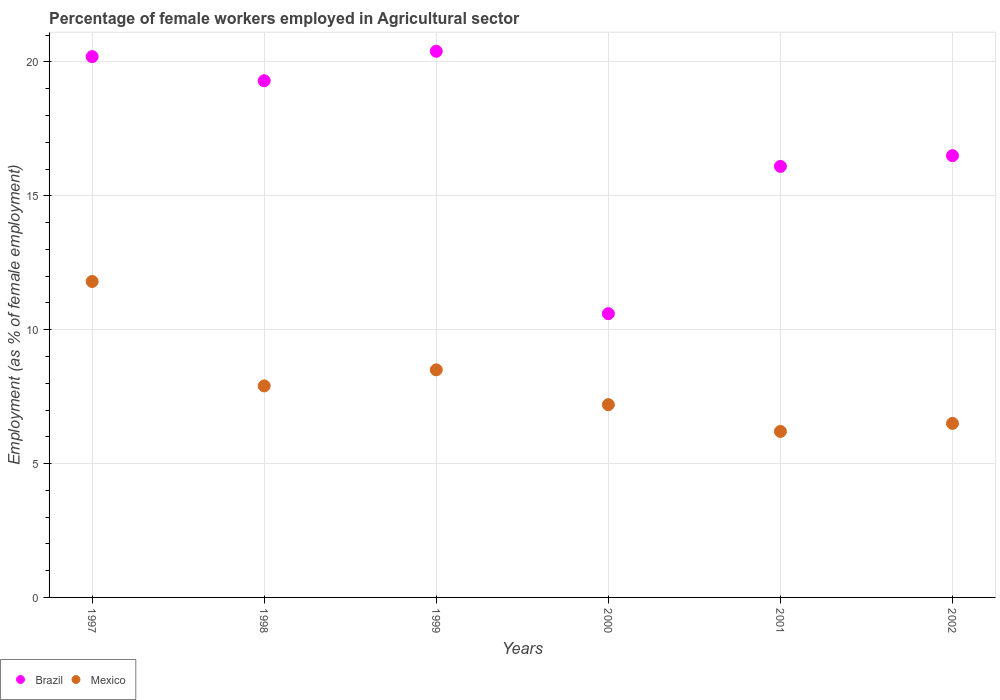Is the number of dotlines equal to the number of legend labels?
Your answer should be very brief. Yes. What is the percentage of females employed in Agricultural sector in Brazil in 2000?
Your answer should be compact. 10.6. Across all years, what is the maximum percentage of females employed in Agricultural sector in Mexico?
Make the answer very short. 11.8. Across all years, what is the minimum percentage of females employed in Agricultural sector in Mexico?
Make the answer very short. 6.2. In which year was the percentage of females employed in Agricultural sector in Brazil minimum?
Offer a very short reply. 2000. What is the total percentage of females employed in Agricultural sector in Mexico in the graph?
Your response must be concise. 48.1. What is the difference between the percentage of females employed in Agricultural sector in Mexico in 1999 and that in 2000?
Keep it short and to the point. 1.3. What is the difference between the percentage of females employed in Agricultural sector in Mexico in 2002 and the percentage of females employed in Agricultural sector in Brazil in 2000?
Make the answer very short. -4.1. What is the average percentage of females employed in Agricultural sector in Brazil per year?
Provide a succinct answer. 17.18. In the year 1997, what is the difference between the percentage of females employed in Agricultural sector in Mexico and percentage of females employed in Agricultural sector in Brazil?
Your response must be concise. -8.4. In how many years, is the percentage of females employed in Agricultural sector in Brazil greater than 11 %?
Your answer should be compact. 5. What is the ratio of the percentage of females employed in Agricultural sector in Brazil in 2000 to that in 2002?
Provide a succinct answer. 0.64. Is the percentage of females employed in Agricultural sector in Brazil in 1997 less than that in 1999?
Offer a very short reply. Yes. Is the difference between the percentage of females employed in Agricultural sector in Mexico in 1999 and 2000 greater than the difference between the percentage of females employed in Agricultural sector in Brazil in 1999 and 2000?
Offer a very short reply. No. What is the difference between the highest and the second highest percentage of females employed in Agricultural sector in Brazil?
Your answer should be very brief. 0.2. What is the difference between the highest and the lowest percentage of females employed in Agricultural sector in Mexico?
Provide a short and direct response. 5.6. In how many years, is the percentage of females employed in Agricultural sector in Mexico greater than the average percentage of females employed in Agricultural sector in Mexico taken over all years?
Your response must be concise. 2. What is the difference between two consecutive major ticks on the Y-axis?
Your answer should be compact. 5. Where does the legend appear in the graph?
Give a very brief answer. Bottom left. How are the legend labels stacked?
Your response must be concise. Horizontal. What is the title of the graph?
Offer a very short reply. Percentage of female workers employed in Agricultural sector. Does "Vietnam" appear as one of the legend labels in the graph?
Your response must be concise. No. What is the label or title of the X-axis?
Your answer should be very brief. Years. What is the label or title of the Y-axis?
Give a very brief answer. Employment (as % of female employment). What is the Employment (as % of female employment) of Brazil in 1997?
Provide a short and direct response. 20.2. What is the Employment (as % of female employment) of Mexico in 1997?
Keep it short and to the point. 11.8. What is the Employment (as % of female employment) of Brazil in 1998?
Ensure brevity in your answer.  19.3. What is the Employment (as % of female employment) in Mexico in 1998?
Ensure brevity in your answer.  7.9. What is the Employment (as % of female employment) in Brazil in 1999?
Make the answer very short. 20.4. What is the Employment (as % of female employment) in Brazil in 2000?
Your answer should be very brief. 10.6. What is the Employment (as % of female employment) of Mexico in 2000?
Offer a very short reply. 7.2. What is the Employment (as % of female employment) in Brazil in 2001?
Provide a succinct answer. 16.1. What is the Employment (as % of female employment) of Mexico in 2001?
Offer a terse response. 6.2. What is the Employment (as % of female employment) in Brazil in 2002?
Provide a short and direct response. 16.5. Across all years, what is the maximum Employment (as % of female employment) in Brazil?
Offer a very short reply. 20.4. Across all years, what is the maximum Employment (as % of female employment) of Mexico?
Ensure brevity in your answer.  11.8. Across all years, what is the minimum Employment (as % of female employment) in Brazil?
Your response must be concise. 10.6. Across all years, what is the minimum Employment (as % of female employment) in Mexico?
Give a very brief answer. 6.2. What is the total Employment (as % of female employment) in Brazil in the graph?
Keep it short and to the point. 103.1. What is the total Employment (as % of female employment) in Mexico in the graph?
Ensure brevity in your answer.  48.1. What is the difference between the Employment (as % of female employment) in Brazil in 1997 and that in 1998?
Make the answer very short. 0.9. What is the difference between the Employment (as % of female employment) in Mexico in 1997 and that in 1999?
Give a very brief answer. 3.3. What is the difference between the Employment (as % of female employment) of Brazil in 1997 and that in 2000?
Offer a terse response. 9.6. What is the difference between the Employment (as % of female employment) of Mexico in 1997 and that in 2001?
Your answer should be very brief. 5.6. What is the difference between the Employment (as % of female employment) of Brazil in 1997 and that in 2002?
Your answer should be compact. 3.7. What is the difference between the Employment (as % of female employment) in Mexico in 1998 and that in 2000?
Make the answer very short. 0.7. What is the difference between the Employment (as % of female employment) of Brazil in 1998 and that in 2001?
Your answer should be very brief. 3.2. What is the difference between the Employment (as % of female employment) in Mexico in 1998 and that in 2002?
Provide a short and direct response. 1.4. What is the difference between the Employment (as % of female employment) in Brazil in 1999 and that in 2000?
Offer a very short reply. 9.8. What is the difference between the Employment (as % of female employment) of Mexico in 2000 and that in 2001?
Provide a short and direct response. 1. What is the difference between the Employment (as % of female employment) in Mexico in 2001 and that in 2002?
Ensure brevity in your answer.  -0.3. What is the difference between the Employment (as % of female employment) of Brazil in 1997 and the Employment (as % of female employment) of Mexico in 1999?
Your answer should be compact. 11.7. What is the difference between the Employment (as % of female employment) in Brazil in 1997 and the Employment (as % of female employment) in Mexico in 2000?
Offer a terse response. 13. What is the difference between the Employment (as % of female employment) in Brazil in 1997 and the Employment (as % of female employment) in Mexico in 2002?
Provide a succinct answer. 13.7. What is the difference between the Employment (as % of female employment) in Brazil in 1998 and the Employment (as % of female employment) in Mexico in 1999?
Make the answer very short. 10.8. What is the difference between the Employment (as % of female employment) in Brazil in 1998 and the Employment (as % of female employment) in Mexico in 2000?
Provide a short and direct response. 12.1. What is the difference between the Employment (as % of female employment) in Brazil in 1998 and the Employment (as % of female employment) in Mexico in 2001?
Your answer should be very brief. 13.1. What is the difference between the Employment (as % of female employment) in Brazil in 1998 and the Employment (as % of female employment) in Mexico in 2002?
Offer a terse response. 12.8. What is the difference between the Employment (as % of female employment) in Brazil in 1999 and the Employment (as % of female employment) in Mexico in 2002?
Offer a very short reply. 13.9. What is the difference between the Employment (as % of female employment) in Brazil in 2000 and the Employment (as % of female employment) in Mexico in 2002?
Your answer should be very brief. 4.1. What is the difference between the Employment (as % of female employment) of Brazil in 2001 and the Employment (as % of female employment) of Mexico in 2002?
Provide a short and direct response. 9.6. What is the average Employment (as % of female employment) of Brazil per year?
Your answer should be compact. 17.18. What is the average Employment (as % of female employment) of Mexico per year?
Provide a short and direct response. 8.02. In the year 1998, what is the difference between the Employment (as % of female employment) in Brazil and Employment (as % of female employment) in Mexico?
Provide a succinct answer. 11.4. In the year 2000, what is the difference between the Employment (as % of female employment) of Brazil and Employment (as % of female employment) of Mexico?
Offer a terse response. 3.4. What is the ratio of the Employment (as % of female employment) in Brazil in 1997 to that in 1998?
Ensure brevity in your answer.  1.05. What is the ratio of the Employment (as % of female employment) of Mexico in 1997 to that in 1998?
Provide a succinct answer. 1.49. What is the ratio of the Employment (as % of female employment) in Brazil in 1997 to that in 1999?
Keep it short and to the point. 0.99. What is the ratio of the Employment (as % of female employment) in Mexico in 1997 to that in 1999?
Your response must be concise. 1.39. What is the ratio of the Employment (as % of female employment) in Brazil in 1997 to that in 2000?
Offer a very short reply. 1.91. What is the ratio of the Employment (as % of female employment) in Mexico in 1997 to that in 2000?
Ensure brevity in your answer.  1.64. What is the ratio of the Employment (as % of female employment) of Brazil in 1997 to that in 2001?
Your answer should be very brief. 1.25. What is the ratio of the Employment (as % of female employment) of Mexico in 1997 to that in 2001?
Provide a short and direct response. 1.9. What is the ratio of the Employment (as % of female employment) of Brazil in 1997 to that in 2002?
Your answer should be very brief. 1.22. What is the ratio of the Employment (as % of female employment) of Mexico in 1997 to that in 2002?
Ensure brevity in your answer.  1.82. What is the ratio of the Employment (as % of female employment) of Brazil in 1998 to that in 1999?
Provide a short and direct response. 0.95. What is the ratio of the Employment (as % of female employment) in Mexico in 1998 to that in 1999?
Your answer should be very brief. 0.93. What is the ratio of the Employment (as % of female employment) in Brazil in 1998 to that in 2000?
Offer a terse response. 1.82. What is the ratio of the Employment (as % of female employment) in Mexico in 1998 to that in 2000?
Your response must be concise. 1.1. What is the ratio of the Employment (as % of female employment) in Brazil in 1998 to that in 2001?
Provide a short and direct response. 1.2. What is the ratio of the Employment (as % of female employment) in Mexico in 1998 to that in 2001?
Your answer should be very brief. 1.27. What is the ratio of the Employment (as % of female employment) of Brazil in 1998 to that in 2002?
Keep it short and to the point. 1.17. What is the ratio of the Employment (as % of female employment) of Mexico in 1998 to that in 2002?
Offer a terse response. 1.22. What is the ratio of the Employment (as % of female employment) of Brazil in 1999 to that in 2000?
Your answer should be very brief. 1.92. What is the ratio of the Employment (as % of female employment) in Mexico in 1999 to that in 2000?
Ensure brevity in your answer.  1.18. What is the ratio of the Employment (as % of female employment) in Brazil in 1999 to that in 2001?
Offer a terse response. 1.27. What is the ratio of the Employment (as % of female employment) of Mexico in 1999 to that in 2001?
Make the answer very short. 1.37. What is the ratio of the Employment (as % of female employment) in Brazil in 1999 to that in 2002?
Offer a very short reply. 1.24. What is the ratio of the Employment (as % of female employment) of Mexico in 1999 to that in 2002?
Provide a succinct answer. 1.31. What is the ratio of the Employment (as % of female employment) of Brazil in 2000 to that in 2001?
Provide a short and direct response. 0.66. What is the ratio of the Employment (as % of female employment) of Mexico in 2000 to that in 2001?
Your response must be concise. 1.16. What is the ratio of the Employment (as % of female employment) of Brazil in 2000 to that in 2002?
Ensure brevity in your answer.  0.64. What is the ratio of the Employment (as % of female employment) in Mexico in 2000 to that in 2002?
Keep it short and to the point. 1.11. What is the ratio of the Employment (as % of female employment) of Brazil in 2001 to that in 2002?
Provide a short and direct response. 0.98. What is the ratio of the Employment (as % of female employment) of Mexico in 2001 to that in 2002?
Provide a succinct answer. 0.95. What is the difference between the highest and the second highest Employment (as % of female employment) of Brazil?
Make the answer very short. 0.2. What is the difference between the highest and the lowest Employment (as % of female employment) in Brazil?
Your answer should be compact. 9.8. 